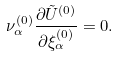Convert formula to latex. <formula><loc_0><loc_0><loc_500><loc_500>\nu _ { \alpha } ^ { ( 0 ) } \frac { \partial \tilde { U } ^ { ( 0 ) } } { \partial \xi _ { \alpha } ^ { ( 0 ) } } = 0 .</formula> 